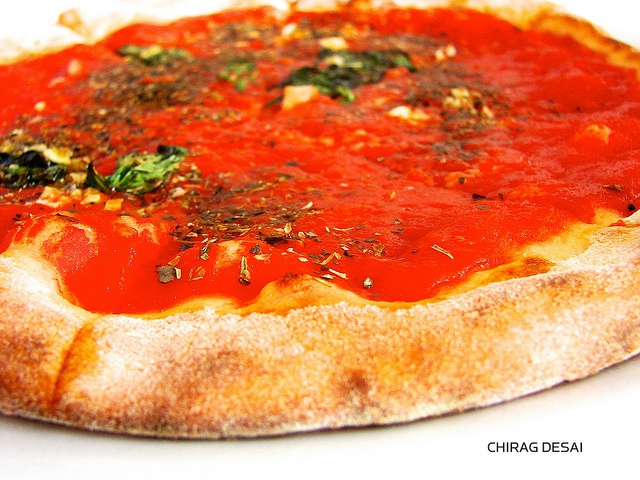Describe the objects in this image and their specific colors. I can see a pizza in red, white, orange, and tan tones in this image. 